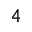<formula> <loc_0><loc_0><loc_500><loc_500>4</formula> 